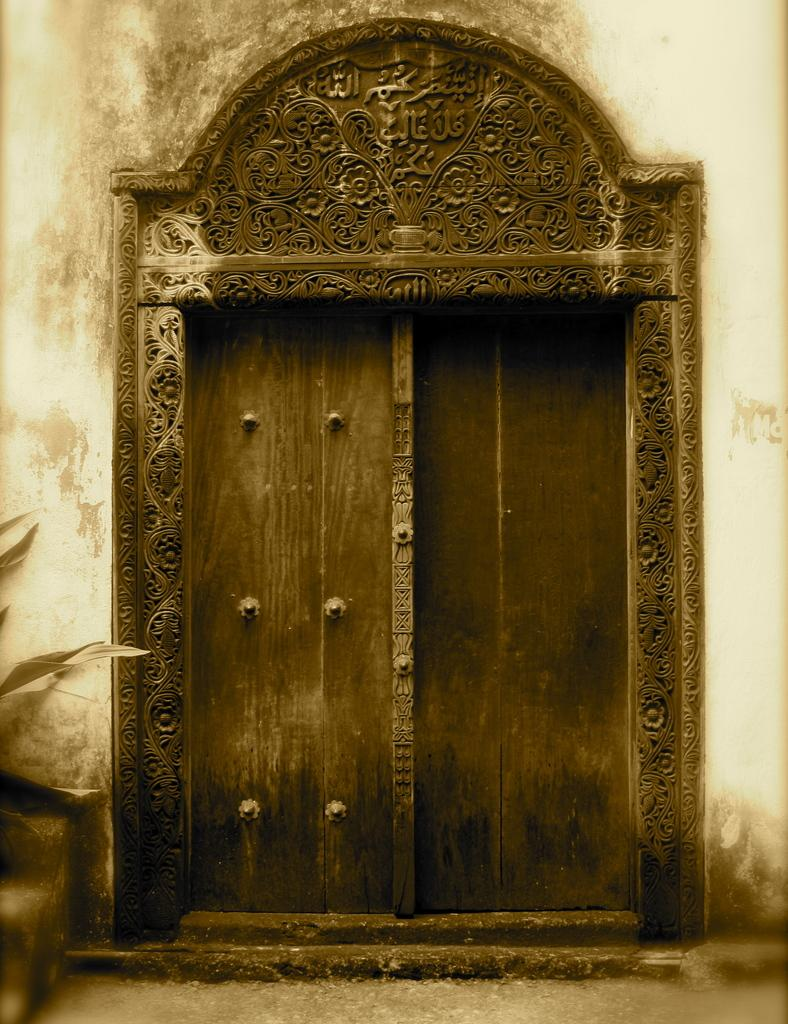What is the main structure visible in the image? There is a wall in the image. What feature is present on the wall? The wall has a door. Can you describe the design around the door? There is a design around the door. What can be seen on the left side of the image? There appears to be a plant on the left side of the image. What type of crime is being committed in the image? There is no indication of any crime being committed in the image. Who is the authority figure in the image? There is no authority figure present in the image. 